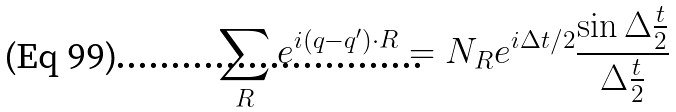<formula> <loc_0><loc_0><loc_500><loc_500>\sum _ { R } e ^ { i ( q - q ^ { \prime } ) \cdot R } = N _ { R } e ^ { i \Delta t / 2 } \frac { \sin \Delta \frac { t } { 2 } } { \Delta \frac { t } { 2 } }</formula> 